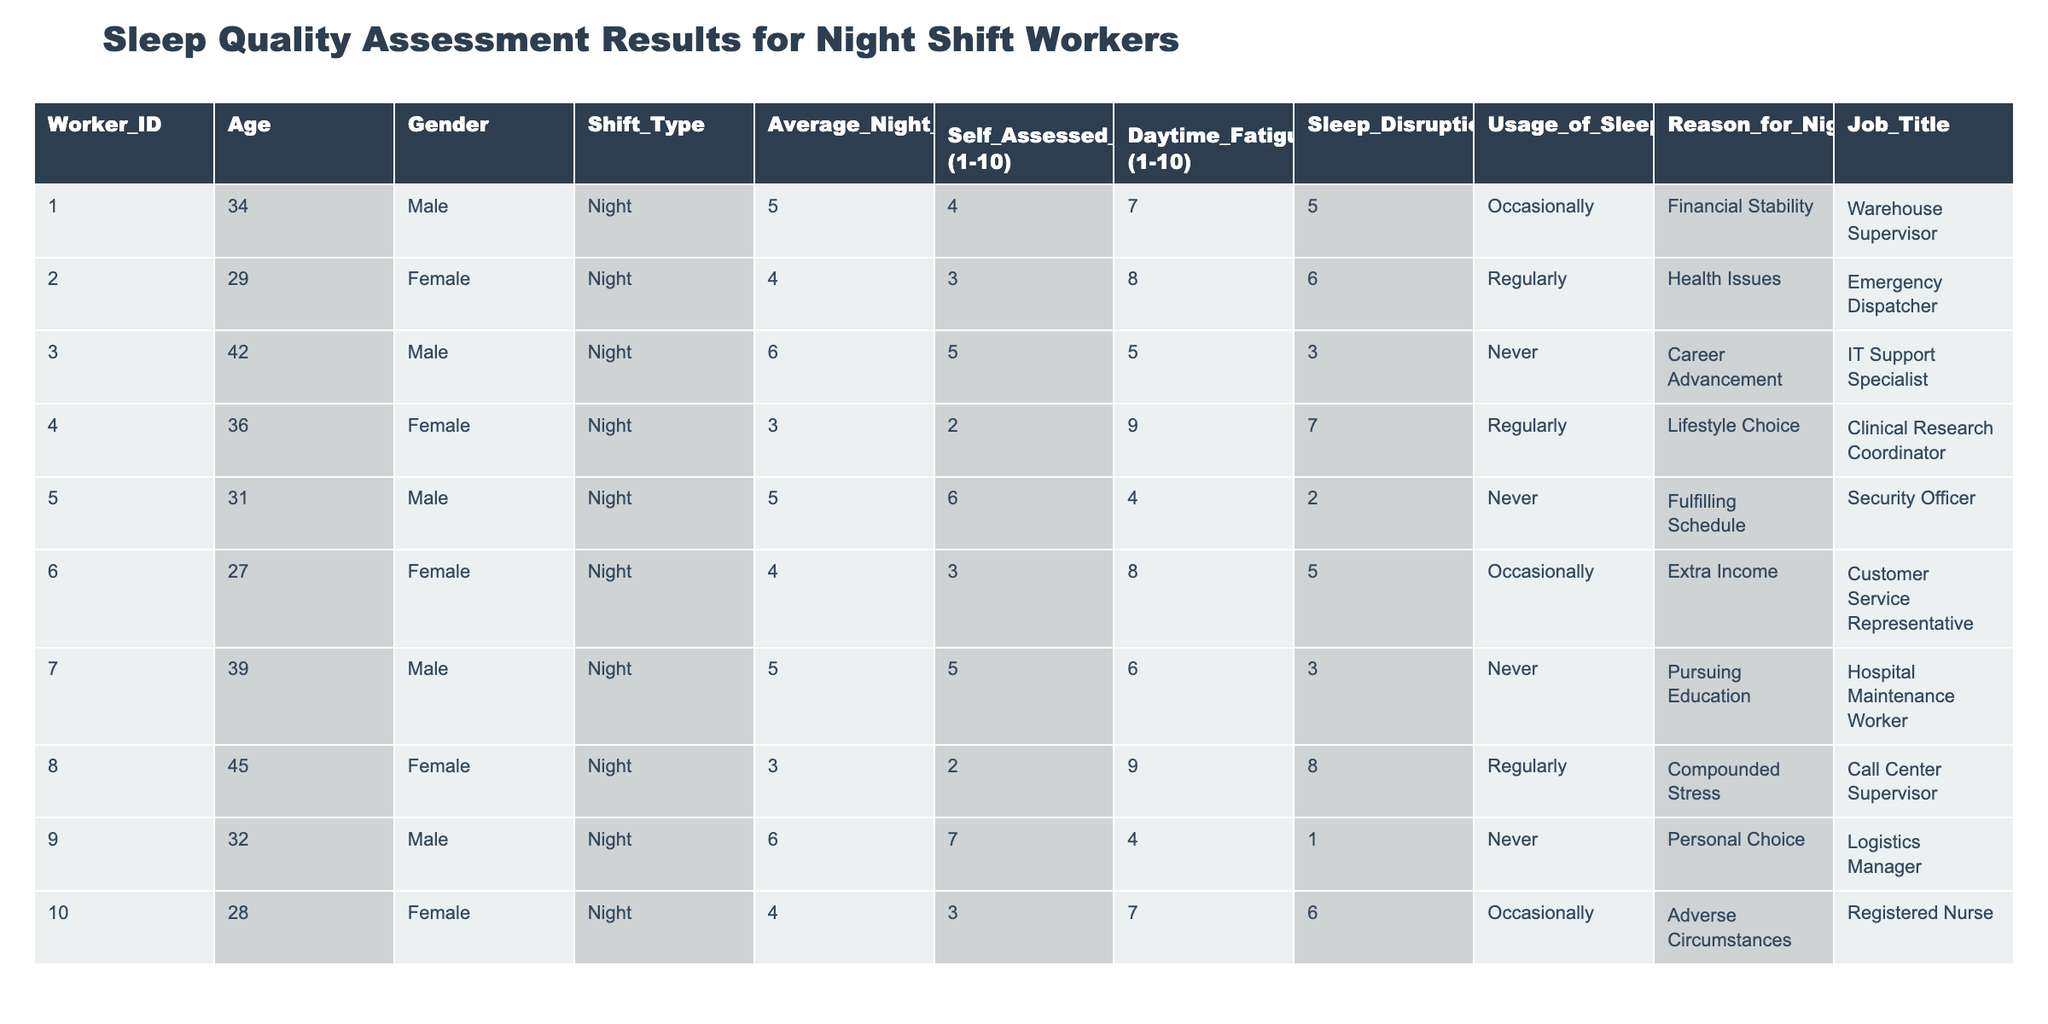What is the average number of sleep hours for the night shift workers? To find the average, I sum the average night sleep hours (5, 4, 6, 3, 5, 4, 5, 3, 6, 4) which equals 4.5. Then, I divide by the number of workers (10) to get 4.5.
Answer: 4.5 How many workers assess their sleep quality as 7 or higher? There are three workers with self-assessed sleep quality scores of 7 or more (Worker 009, Worker 005, Worker 003).
Answer: 3 Is there a worker who does not use sleep aids and rates their sleep quality as 8 or above? Worker 009 does not use sleep aids and rates their sleep quality as 7. Therefore, the statement is false as none meet the criteria of 8 or above.
Answer: No What is the relationship between the average night sleep hours and daytime fatigue levels? Analyzing the workers, those who sleep longer hours like Worker 009 report lower daytime fatigue (4) compared to those who sleep less, emphasizing a negative correlation between sleep hours and fatigue levels.
Answer: Negative correlation Which worker has the highest self-assessed sleep quality and what is their job title? Worker 009 has the highest self-assessed sleep quality of 7 and their job title is Logistics Manager.
Answer: Logistics Manager How many workers report sleep disruptions of 5 or more per week? Three workers report 5 or more sleep disruptions per week (Workers 001, 002, 004). So, I count and find the total is 3.
Answer: 3 What is the average daytime fatigue level among those who never use sleep aids? The daytime fatigue levels of those who never use sleep aids are (5, 4, 6) for Workers 005, 003, and 007. Summing these gives 15, and the average is 15/3, which equals 5.
Answer: 5 Is the average self-assessed sleep quality of female workers higher than that of male workers? Female workers have self-assessed sleep qualities of (3, 2, 3) totaling 8, calculating an average of 2.67. Male workers have qualities (4, 5, 6, 7) totaling 22 with an average of 5.5, confirming the males have higher average sleep quality.
Answer: No Which job title has the lowest average night sleep hours and how many sleep disruptions do they have? The Clinical Research Coordinator (Worker 004) has the lowest average night sleep hours of 3. They also report 7 sleep disruptions per week.
Answer: 7 disruptions How many workers have a daytime fatigue level above 6? From the table, four workers exceed a daytime fatigue level of 6 (Workers 001, 002, 004, 008). Thus, I verify their scores and find the count is correct.
Answer: 4 